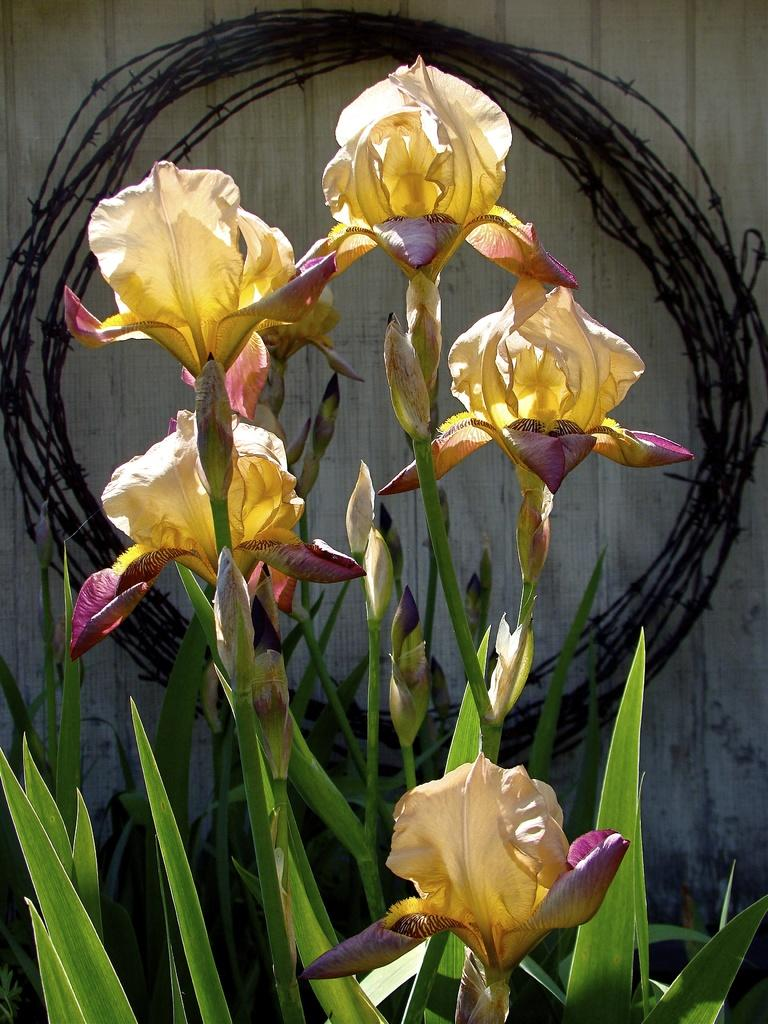What type of living organisms can be seen in the image? Plants can be seen in the image. What is visible in the background of the image? There is a wall in the background of the image. How many voyages have the eyes in the image been on? There are no eyes present in the image, so it is not possible to determine how many voyages they have been on. 